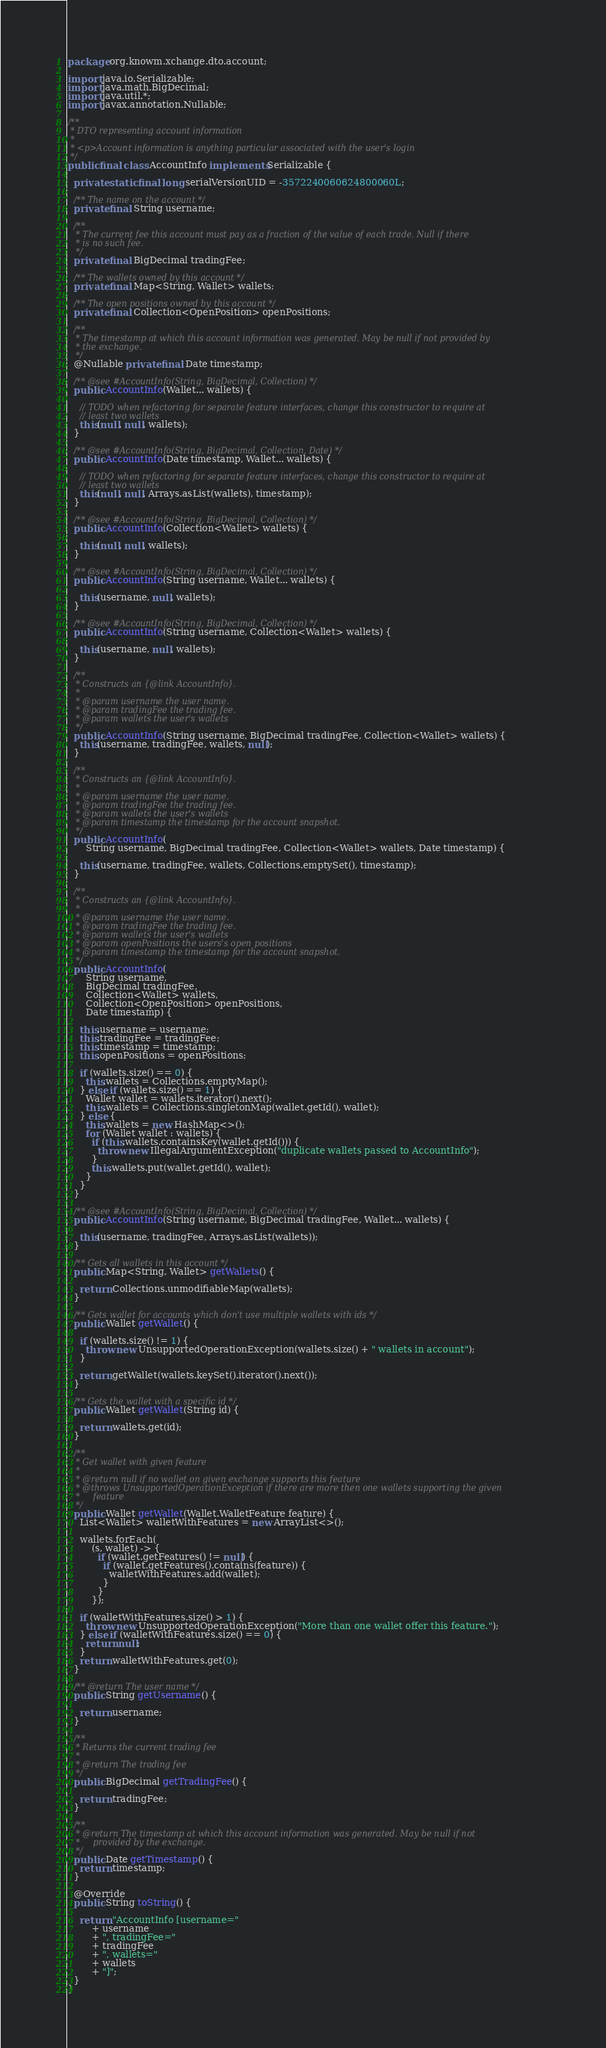<code> <loc_0><loc_0><loc_500><loc_500><_Java_>package org.knowm.xchange.dto.account;

import java.io.Serializable;
import java.math.BigDecimal;
import java.util.*;
import javax.annotation.Nullable;

/**
 * DTO representing account information
 *
 * <p>Account information is anything particular associated with the user's login
 */
public final class AccountInfo implements Serializable {

  private static final long serialVersionUID = -3572240060624800060L;

  /** The name on the account */
  private final String username;

  /**
   * The current fee this account must pay as a fraction of the value of each trade. Null if there
   * is no such fee.
   */
  private final BigDecimal tradingFee;

  /** The wallets owned by this account */
  private final Map<String, Wallet> wallets;

  /** The open positions owned by this account */
  private final Collection<OpenPosition> openPositions;

  /**
   * The timestamp at which this account information was generated. May be null if not provided by
   * the exchange.
   */
  @Nullable private final Date timestamp;

  /** @see #AccountInfo(String, BigDecimal, Collection) */
  public AccountInfo(Wallet... wallets) {

    // TODO when refactoring for separate feature interfaces, change this constructor to require at
    // least two wallets
    this(null, null, wallets);
  }

  /** @see #AccountInfo(String, BigDecimal, Collection, Date) */
  public AccountInfo(Date timestamp, Wallet... wallets) {

    // TODO when refactoring for separate feature interfaces, change this constructor to require at
    // least two wallets
    this(null, null, Arrays.asList(wallets), timestamp);
  }

  /** @see #AccountInfo(String, BigDecimal, Collection) */
  public AccountInfo(Collection<Wallet> wallets) {

    this(null, null, wallets);
  }

  /** @see #AccountInfo(String, BigDecimal, Collection) */
  public AccountInfo(String username, Wallet... wallets) {

    this(username, null, wallets);
  }

  /** @see #AccountInfo(String, BigDecimal, Collection) */
  public AccountInfo(String username, Collection<Wallet> wallets) {

    this(username, null, wallets);
  }

  /**
   * Constructs an {@link AccountInfo}.
   *
   * @param username the user name.
   * @param tradingFee the trading fee.
   * @param wallets the user's wallets
   */
  public AccountInfo(String username, BigDecimal tradingFee, Collection<Wallet> wallets) {
    this(username, tradingFee, wallets, null);
  }

  /**
   * Constructs an {@link AccountInfo}.
   *
   * @param username the user name.
   * @param tradingFee the trading fee.
   * @param wallets the user's wallets
   * @param timestamp the timestamp for the account snapshot.
   */
  public AccountInfo(
      String username, BigDecimal tradingFee, Collection<Wallet> wallets, Date timestamp) {

    this(username, tradingFee, wallets, Collections.emptySet(), timestamp);
  }

  /**
   * Constructs an {@link AccountInfo}.
   *
   * @param username the user name.
   * @param tradingFee the trading fee.
   * @param wallets the user's wallets
   * @param openPositions the users's open positions
   * @param timestamp the timestamp for the account snapshot.
   */
  public AccountInfo(
      String username,
      BigDecimal tradingFee,
      Collection<Wallet> wallets,
      Collection<OpenPosition> openPositions,
      Date timestamp) {

    this.username = username;
    this.tradingFee = tradingFee;
    this.timestamp = timestamp;
    this.openPositions = openPositions;

    if (wallets.size() == 0) {
      this.wallets = Collections.emptyMap();
    } else if (wallets.size() == 1) {
      Wallet wallet = wallets.iterator().next();
      this.wallets = Collections.singletonMap(wallet.getId(), wallet);
    } else {
      this.wallets = new HashMap<>();
      for (Wallet wallet : wallets) {
        if (this.wallets.containsKey(wallet.getId())) {
          throw new IllegalArgumentException("duplicate wallets passed to AccountInfo");
        }
        this.wallets.put(wallet.getId(), wallet);
      }
    }
  }

  /** @see #AccountInfo(String, BigDecimal, Collection) */
  public AccountInfo(String username, BigDecimal tradingFee, Wallet... wallets) {

    this(username, tradingFee, Arrays.asList(wallets));
  }

  /** Gets all wallets in this account */
  public Map<String, Wallet> getWallets() {

    return Collections.unmodifiableMap(wallets);
  }

  /** Gets wallet for accounts which don't use multiple wallets with ids */
  public Wallet getWallet() {

    if (wallets.size() != 1) {
      throw new UnsupportedOperationException(wallets.size() + " wallets in account");
    }

    return getWallet(wallets.keySet().iterator().next());
  }

  /** Gets the wallet with a specific id */
  public Wallet getWallet(String id) {

    return wallets.get(id);
  }

  /**
   * Get wallet with given feature
   *
   * @return null if no wallet on given exchange supports this feature
   * @throws UnsupportedOperationException if there are more then one wallets supporting the given
   *     feature
   */
  public Wallet getWallet(Wallet.WalletFeature feature) {
    List<Wallet> walletWithFeatures = new ArrayList<>();

    wallets.forEach(
        (s, wallet) -> {
          if (wallet.getFeatures() != null) {
            if (wallet.getFeatures().contains(feature)) {
              walletWithFeatures.add(wallet);
            }
          }
        });

    if (walletWithFeatures.size() > 1) {
      throw new UnsupportedOperationException("More than one wallet offer this feature.");
    } else if (walletWithFeatures.size() == 0) {
      return null;
    }
    return walletWithFeatures.get(0);
  }

  /** @return The user name */
  public String getUsername() {

    return username;
  }

  /**
   * Returns the current trading fee
   *
   * @return The trading fee
   */
  public BigDecimal getTradingFee() {

    return tradingFee;
  }

  /**
   * @return The timestamp at which this account information was generated. May be null if not
   *     provided by the exchange.
   */
  public Date getTimestamp() {
    return timestamp;
  }

  @Override
  public String toString() {

    return "AccountInfo [username="
        + username
        + ", tradingFee="
        + tradingFee
        + ", wallets="
        + wallets
        + "]";
  }
}
</code> 